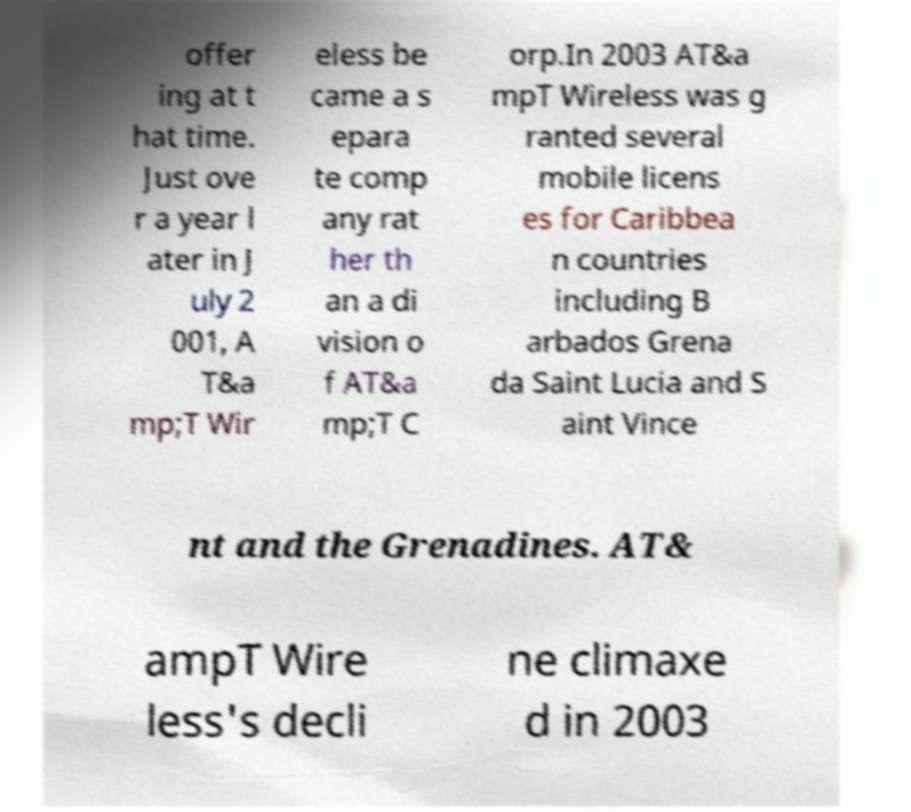Please identify and transcribe the text found in this image. offer ing at t hat time. Just ove r a year l ater in J uly 2 001, A T&a mp;T Wir eless be came a s epara te comp any rat her th an a di vision o f AT&a mp;T C orp.In 2003 AT&a mpT Wireless was g ranted several mobile licens es for Caribbea n countries including B arbados Grena da Saint Lucia and S aint Vince nt and the Grenadines. AT& ampT Wire less's decli ne climaxe d in 2003 